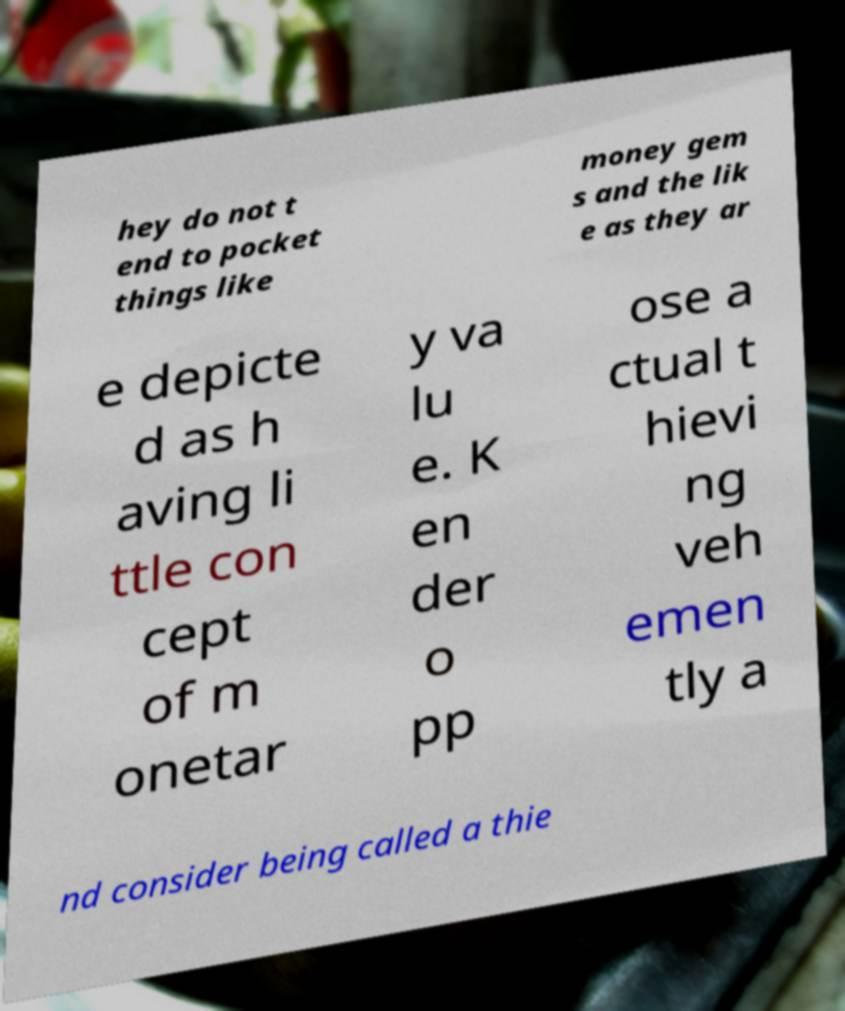I need the written content from this picture converted into text. Can you do that? hey do not t end to pocket things like money gem s and the lik e as they ar e depicte d as h aving li ttle con cept of m onetar y va lu e. K en der o pp ose a ctual t hievi ng veh emen tly a nd consider being called a thie 